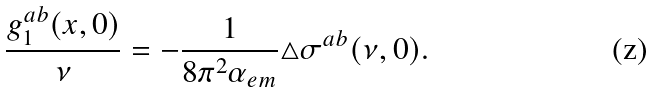<formula> <loc_0><loc_0><loc_500><loc_500>\frac { g _ { 1 } ^ { a b } ( x , 0 ) } { \nu } = - \frac { 1 } { 8 \pi ^ { 2 } \alpha _ { e m } } \triangle \sigma ^ { a b } ( \nu , 0 ) .</formula> 